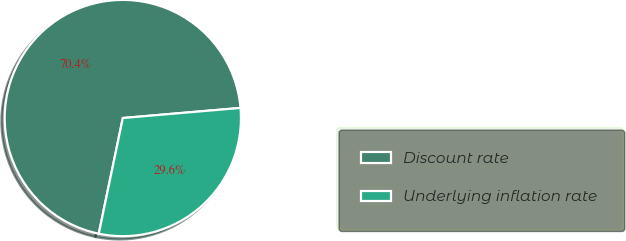Convert chart to OTSL. <chart><loc_0><loc_0><loc_500><loc_500><pie_chart><fcel>Discount rate<fcel>Underlying inflation rate<nl><fcel>70.37%<fcel>29.63%<nl></chart> 